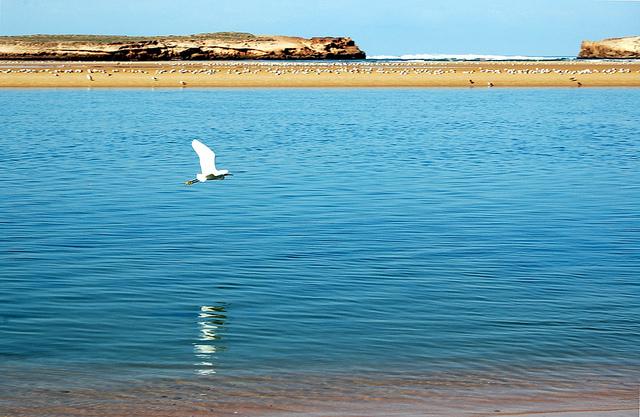What color is the water?
Write a very short answer. Blue. What type of bird is flying over water?
Write a very short answer. Seagull. What reflection can be seen in the water?
Concise answer only. Bird. 